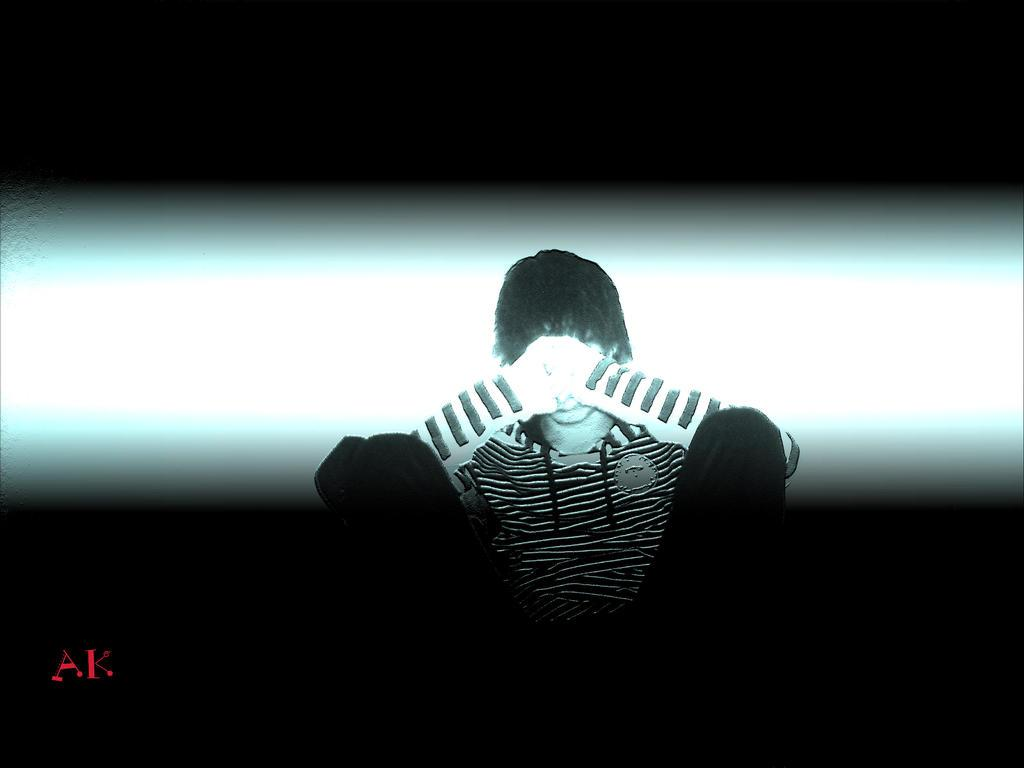What is the person in the image doing? There is a person sitting in the image. What is behind the person in the image? There is a wall behind the person. How is the person being illuminated in the image? Light is falling on the person. What can be seen at the bottom of the image? There is text at the bottom of the image. What type of cookware is the goldfish using in the image? There is no cookware or goldfish present in the image. 